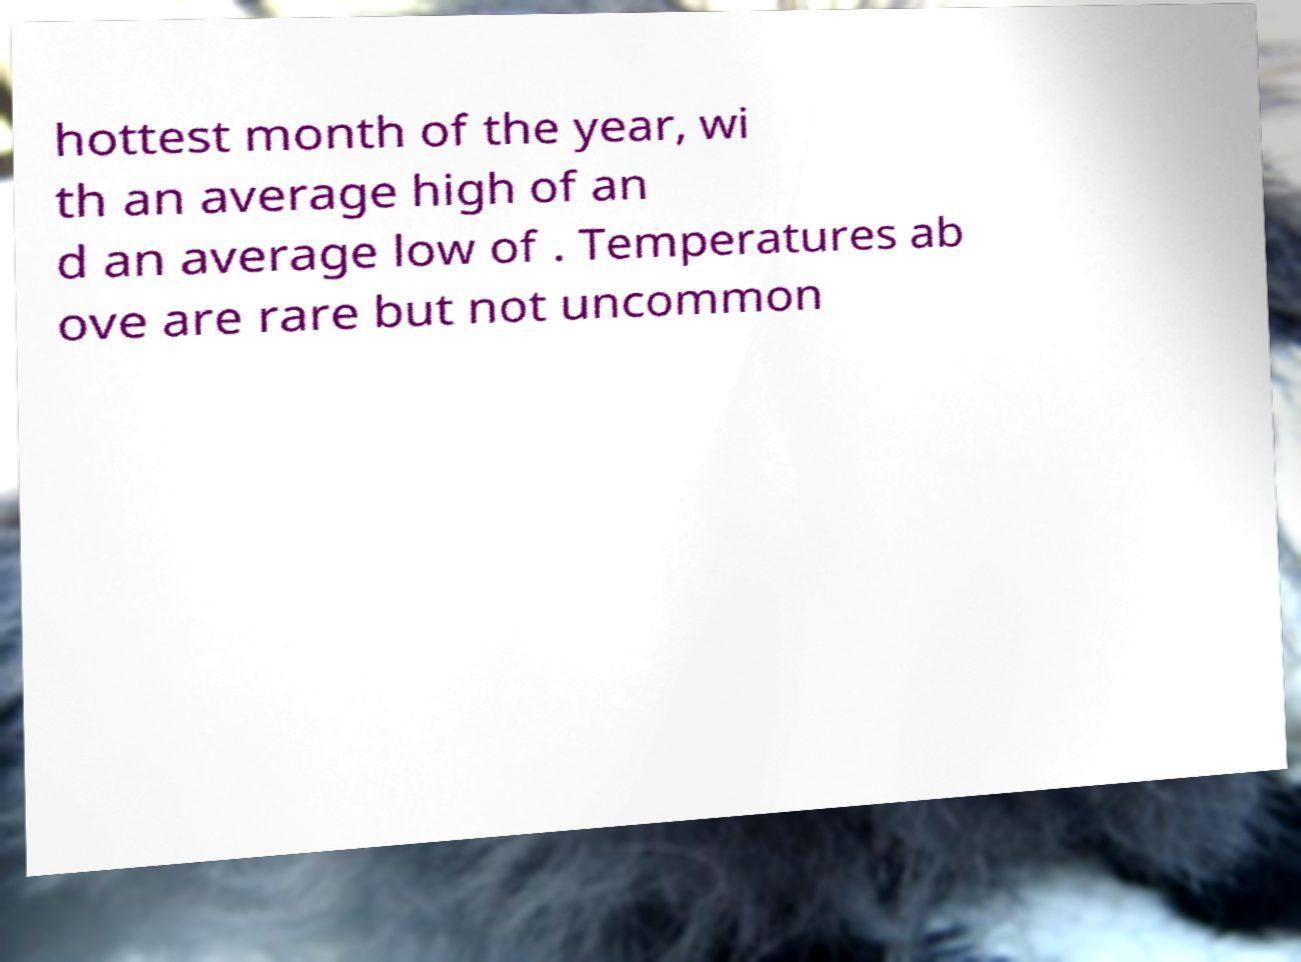There's text embedded in this image that I need extracted. Can you transcribe it verbatim? hottest month of the year, wi th an average high of an d an average low of . Temperatures ab ove are rare but not uncommon 